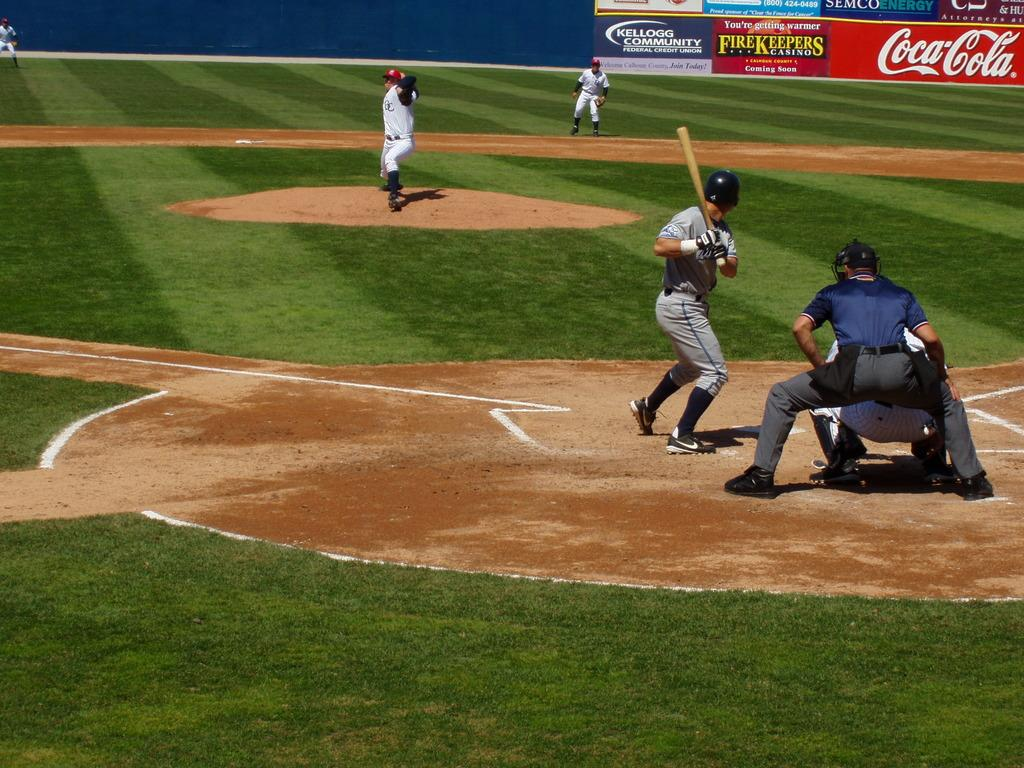<image>
Present a compact description of the photo's key features. Baseball game in progress sponsored by Coca Cola and FireKeepers. 